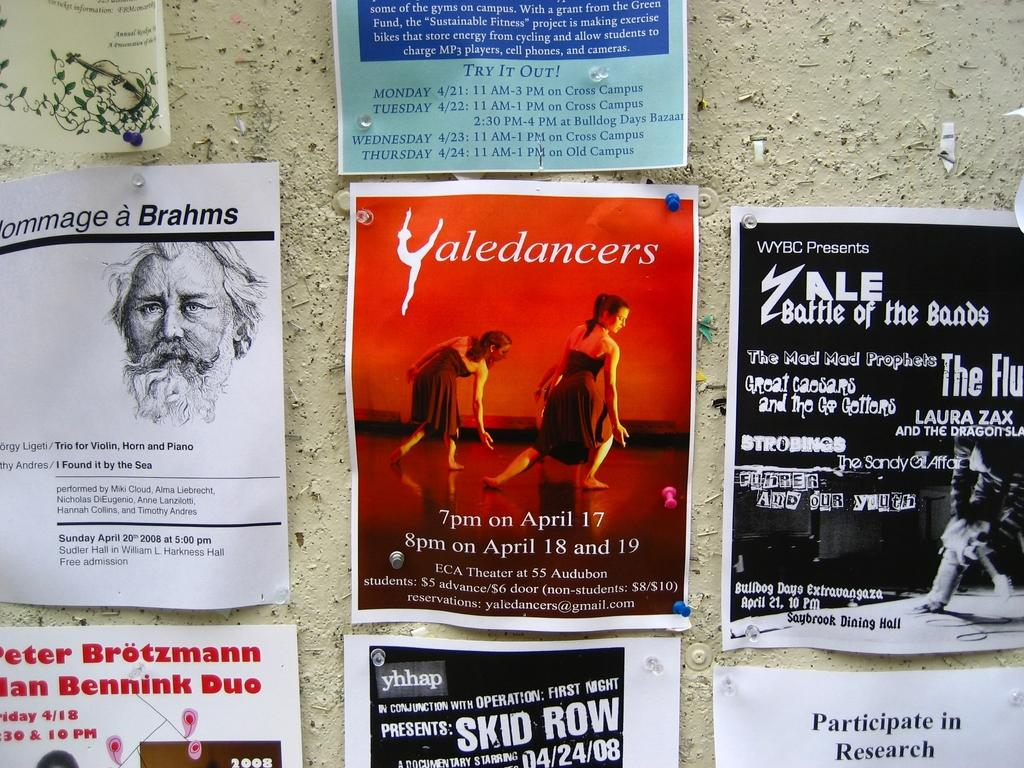<image>
Present a compact description of the photo's key features. A bulletin board shows a poster for Yaledancers 